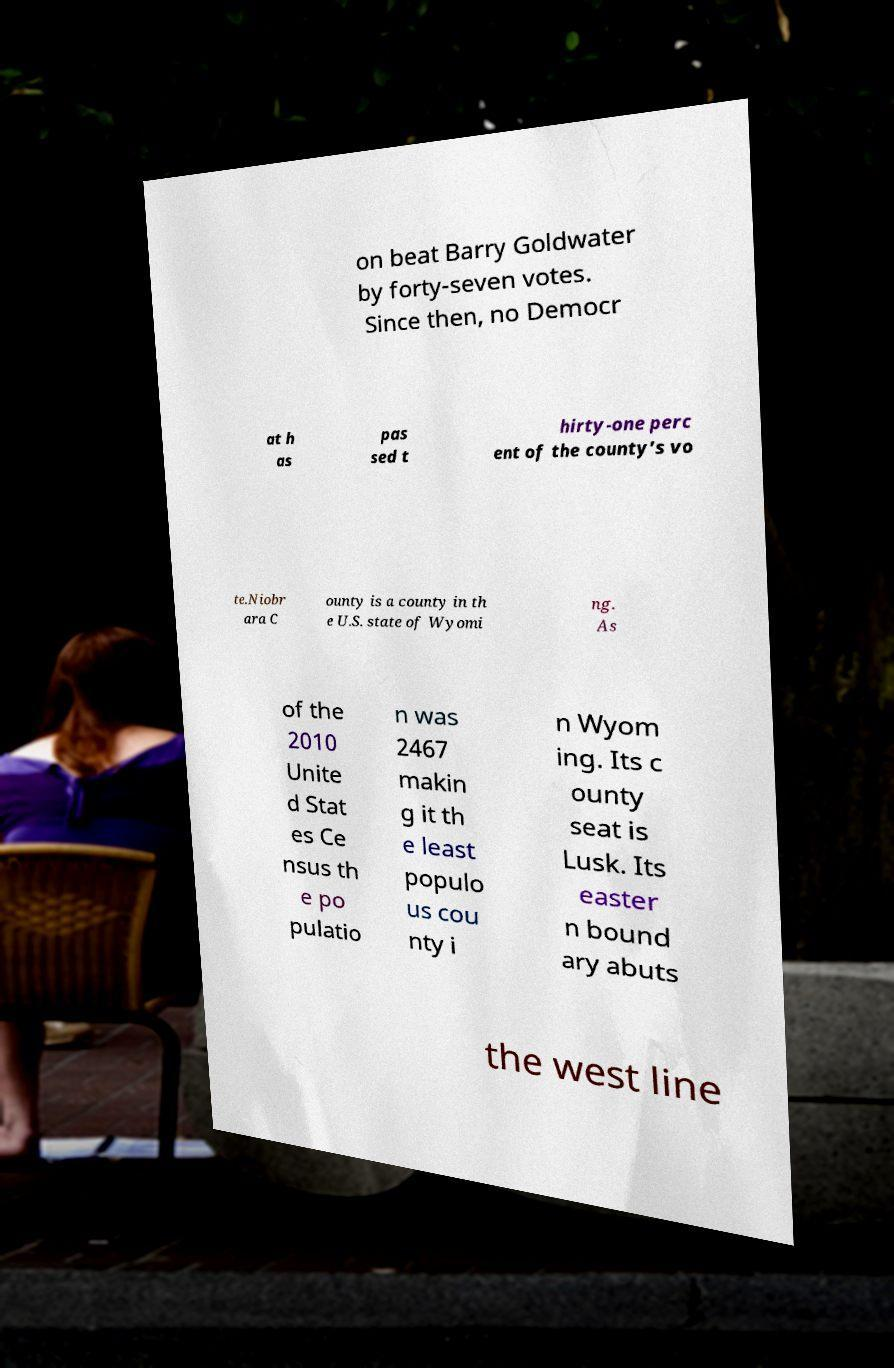I need the written content from this picture converted into text. Can you do that? on beat Barry Goldwater by forty-seven votes. Since then, no Democr at h as pas sed t hirty-one perc ent of the county’s vo te.Niobr ara C ounty is a county in th e U.S. state of Wyomi ng. As of the 2010 Unite d Stat es Ce nsus th e po pulatio n was 2467 makin g it th e least populo us cou nty i n Wyom ing. Its c ounty seat is Lusk. Its easter n bound ary abuts the west line 